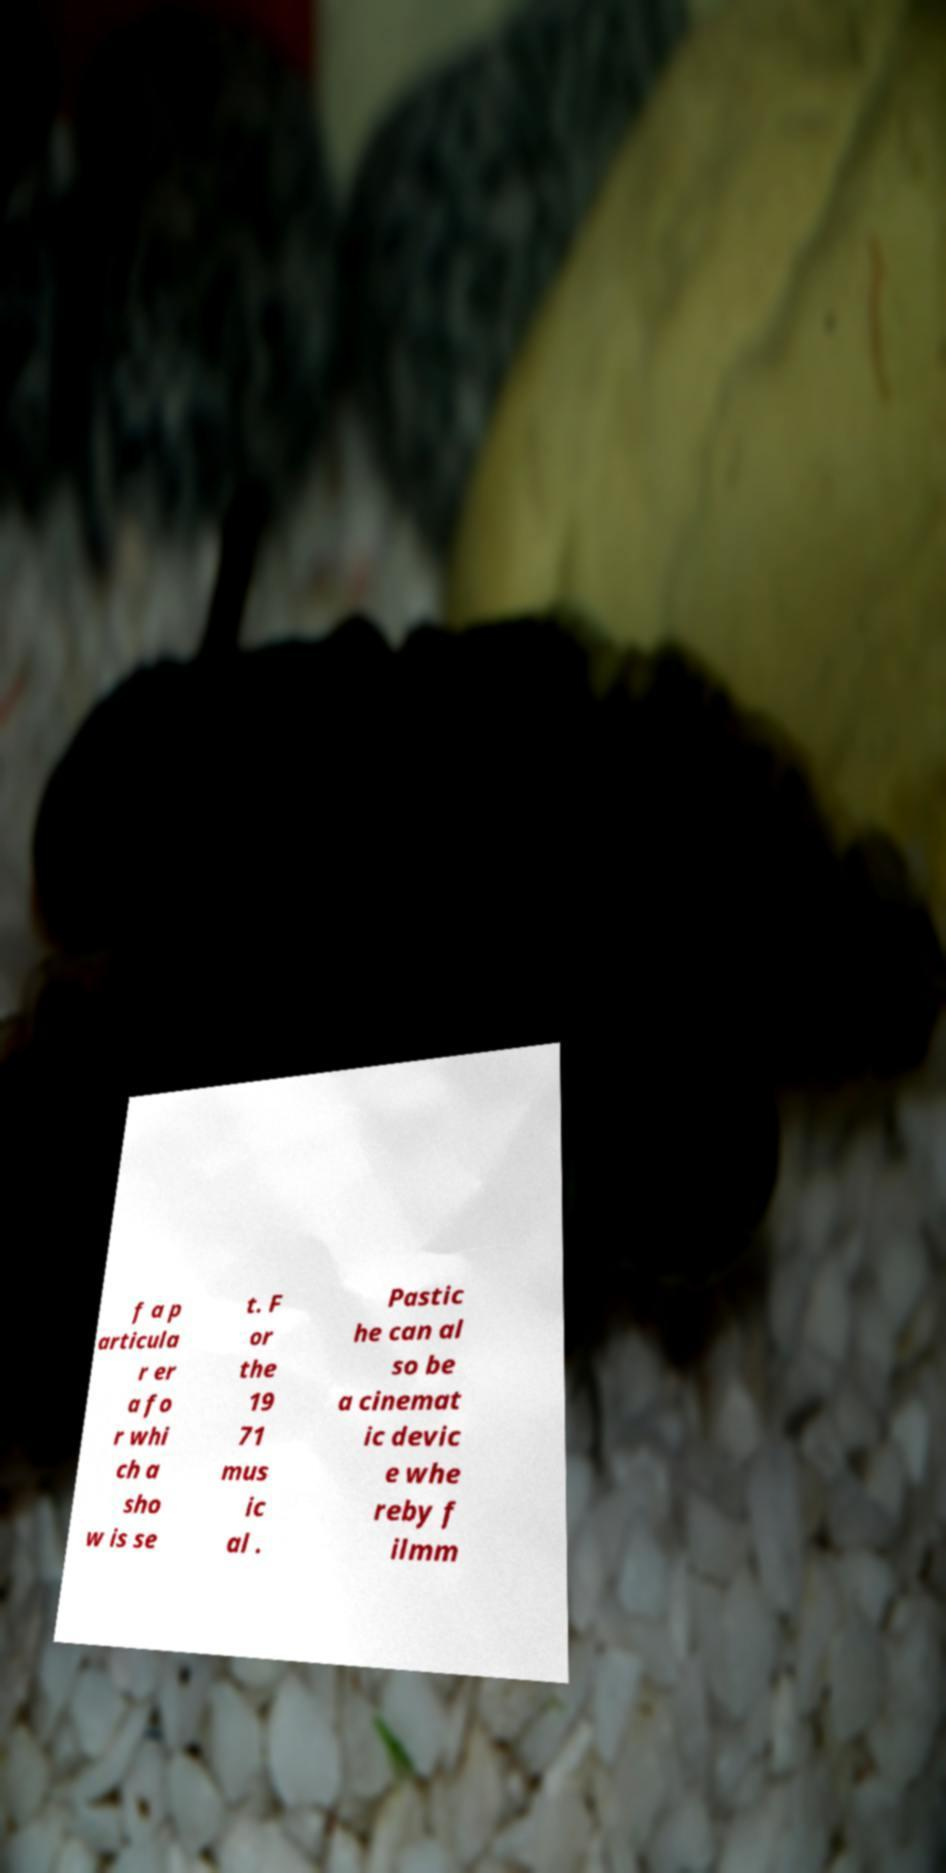Can you read and provide the text displayed in the image?This photo seems to have some interesting text. Can you extract and type it out for me? f a p articula r er a fo r whi ch a sho w is se t. F or the 19 71 mus ic al . Pastic he can al so be a cinemat ic devic e whe reby f ilmm 